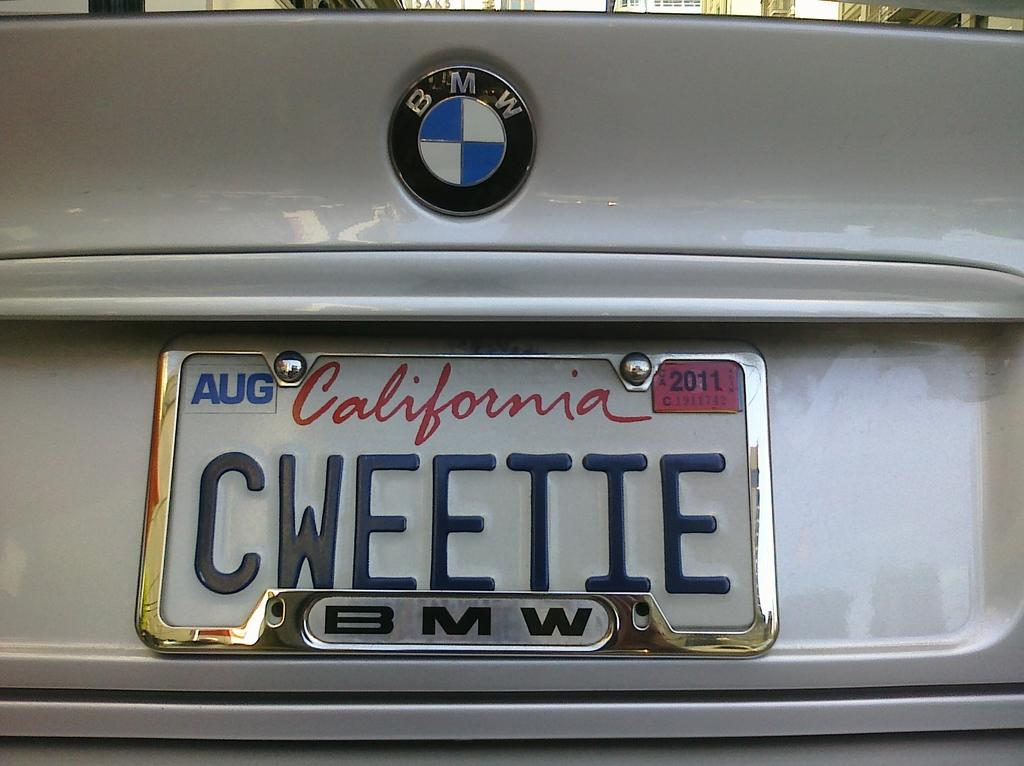<image>
Write a terse but informative summary of the picture. Car with a California license plate which says CWEETIE. 